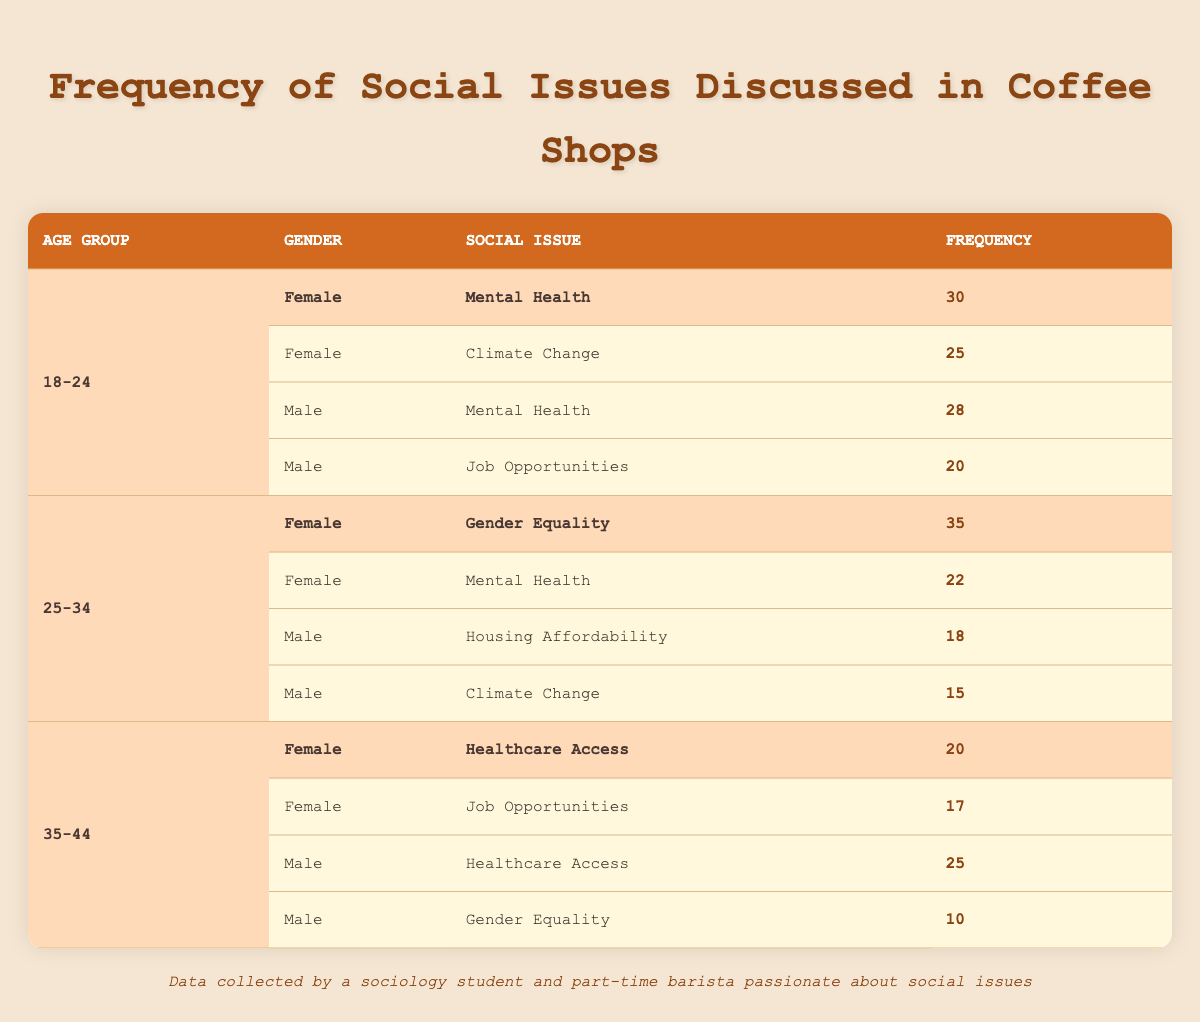What is the most frequently discussed social issue among 18-24-year-old females? In the data for 18-24-year-old females, the frequency of social issues discussed includes Mental Health (30) and Climate Change (25). The highest frequency is for Mental Health at 30.
Answer: Mental Health What is the total frequency of social issues discussed by 25-34-year-old males? The frequency for 25-34-year-old males includes Housing Affordability (18) and Climate Change (15). Summing these values gives 18 + 15 = 33.
Answer: 33 Is Gender Equality discussed more frequently by females than males in the 25-34 age group? For the 25-34 age group, Gender Equality is discussed by females at a frequency of 35, while males have a frequency of 10. Since 35 is greater than 10, the statement is true.
Answer: Yes What is the average frequency of social issues discussed by 35-44-year-old females? The 35-44-year-old females discussed Healthcare Access (20) and Job Opportunities (17). Adding them gives 20 + 17 = 37, then dividing by 2 (the number of issues) leads to an average of 37 / 2 = 18.5.
Answer: 18.5 Which gender in the 18-24 age group discussed Job Opportunities, and what was the frequency? In the 18-24 age group, Job Opportunities was discussed by males with a frequency of 20, while females did not mention this issue.
Answer: Male, 20 What is the total frequency of Mental Health discussions across all age groups and genders? The frequency of Mental Health discussions includes 30 for 18-24-year-old females, 28 for 18-24-year-old males, and 22 for 25-34-year-old females, totaling 30 + 28 + 22 = 80.
Answer: 80 Is Climate Change discussed less frequently by 25-34-year-old males compared to 18-24-year-old females? For 25-34-year-old males, Climate Change is discussed with a frequency of 15, while it is discussed by 18-24-year-old females with a frequency of 25. Since 15 is less than 25, the statement is true.
Answer: Yes What is the least discussed social issue among 35-44-year-old males? The 35-44-year-old males discussed Healthcare Access (25) and Gender Equality (10). The least discussed issue is Gender Equality, which has a frequency of 10.
Answer: Gender Equality, 10 What is the difference in frequency between the most and least discussed social issues among 25-34-year-old females? The most discussed issue for 25-34-year-old females is Gender Equality (35) and the least is Mental Health (22). The difference is 35 - 22 = 13.
Answer: 13 